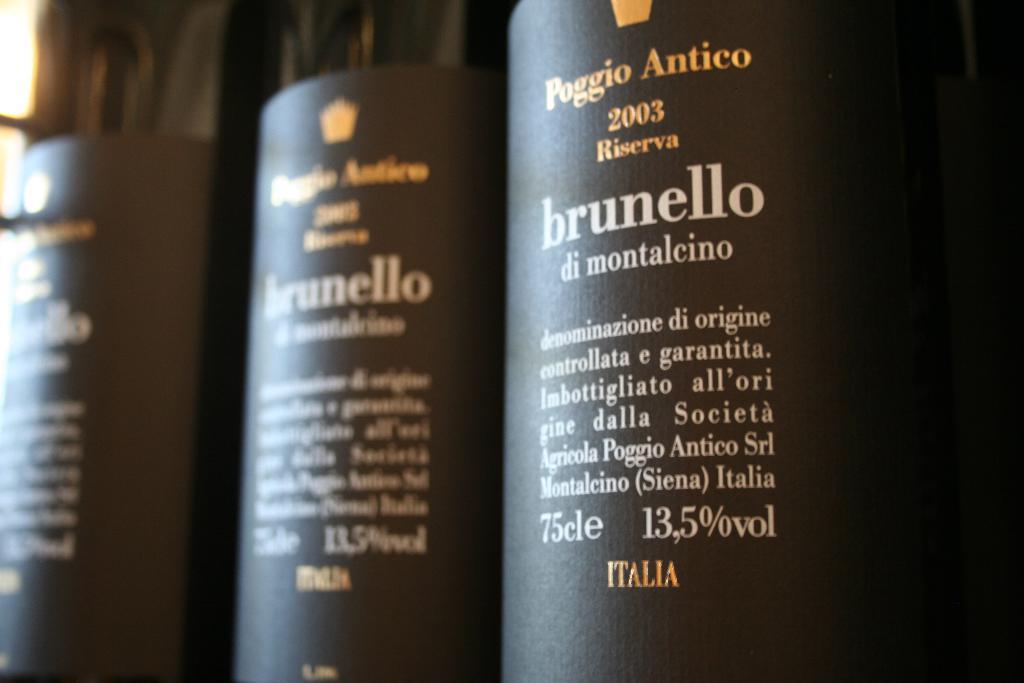What is the brand of the wine?
Ensure brevity in your answer.  Poggio antico. Where what this drink made?
Make the answer very short. Italia. 